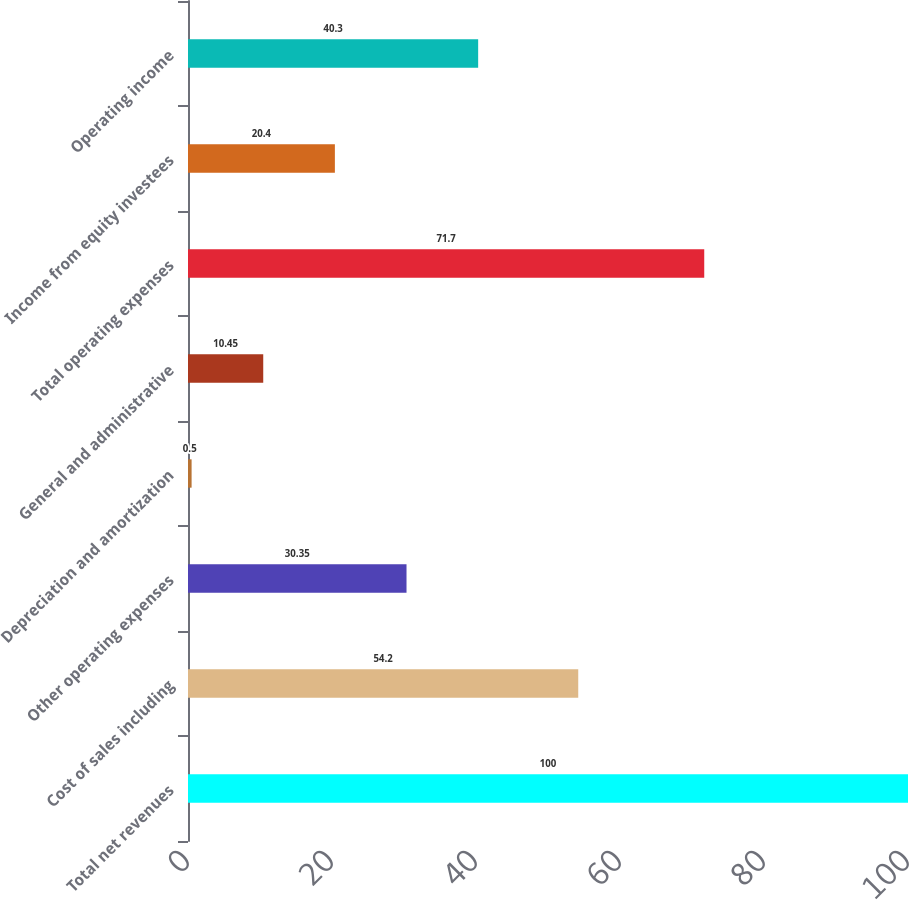<chart> <loc_0><loc_0><loc_500><loc_500><bar_chart><fcel>Total net revenues<fcel>Cost of sales including<fcel>Other operating expenses<fcel>Depreciation and amortization<fcel>General and administrative<fcel>Total operating expenses<fcel>Income from equity investees<fcel>Operating income<nl><fcel>100<fcel>54.2<fcel>30.35<fcel>0.5<fcel>10.45<fcel>71.7<fcel>20.4<fcel>40.3<nl></chart> 